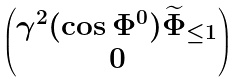<formula> <loc_0><loc_0><loc_500><loc_500>\begin{pmatrix} \gamma ^ { 2 } ( \cos \Phi ^ { 0 } ) \widetilde { \Phi } _ { \leq 1 } \\ 0 \end{pmatrix}</formula> 